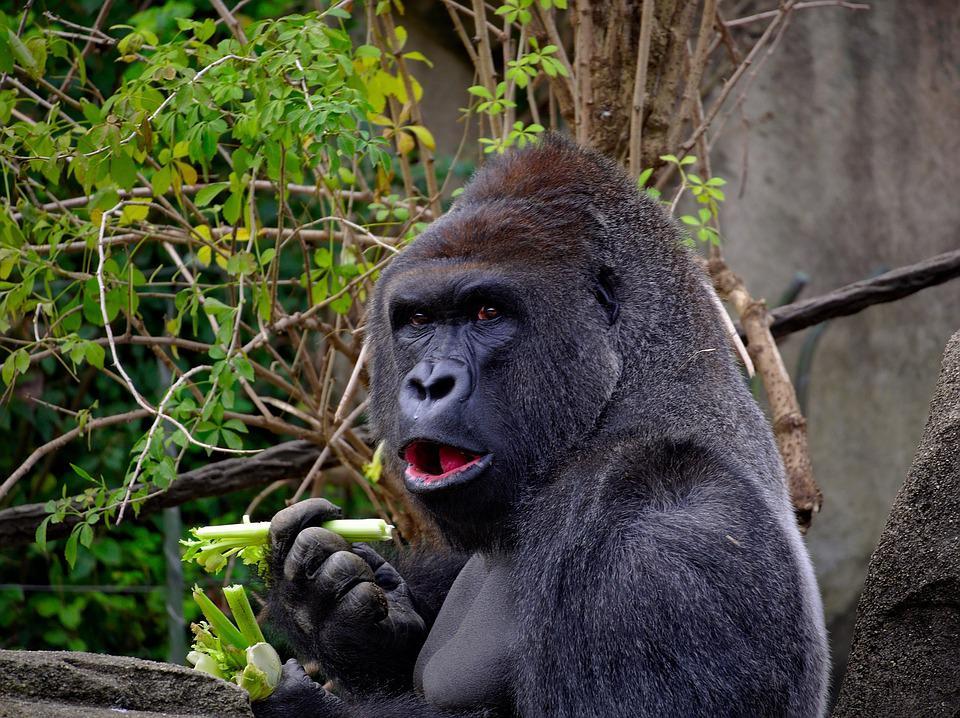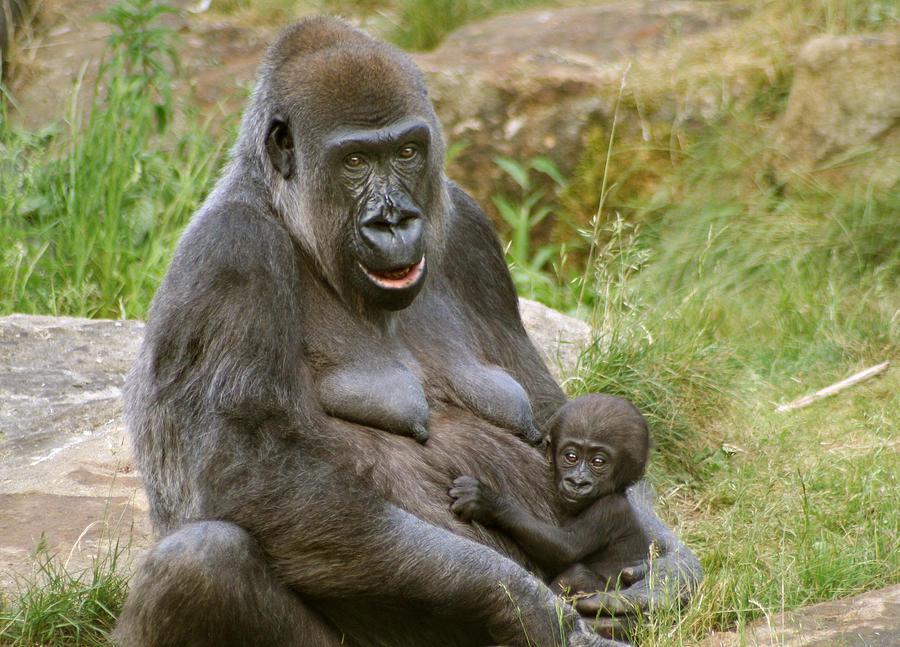The first image is the image on the left, the second image is the image on the right. Given the left and right images, does the statement "One image shows a man interacting with a gorilla, with one of them in front of the other but their bodies not facing, and the man is holding on to one of the gorilla's hands." hold true? Answer yes or no. No. The first image is the image on the left, the second image is the image on the right. For the images displayed, is the sentence "I human is interacting with an ape." factually correct? Answer yes or no. No. 